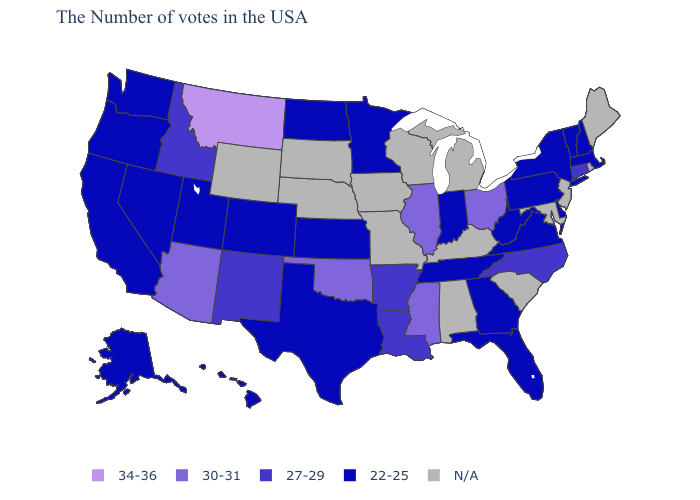Among the states that border Oklahoma , does Arkansas have the highest value?
Keep it brief. Yes. What is the value of Ohio?
Keep it brief. 30-31. Among the states that border Texas , does Louisiana have the lowest value?
Write a very short answer. Yes. Does the first symbol in the legend represent the smallest category?
Answer briefly. No. What is the highest value in the West ?
Quick response, please. 34-36. Among the states that border Connecticut , does Rhode Island have the lowest value?
Concise answer only. No. Does the first symbol in the legend represent the smallest category?
Concise answer only. No. Which states have the lowest value in the MidWest?
Short answer required. Indiana, Minnesota, Kansas, North Dakota. Name the states that have a value in the range 30-31?
Keep it brief. Ohio, Illinois, Mississippi, Oklahoma, Arizona. Name the states that have a value in the range 27-29?
Give a very brief answer. Connecticut, North Carolina, Louisiana, Arkansas, New Mexico, Idaho. Does Rhode Island have the highest value in the Northeast?
Write a very short answer. Yes. Does Tennessee have the lowest value in the South?
Write a very short answer. Yes. Among the states that border Delaware , which have the lowest value?
Answer briefly. Pennsylvania. 